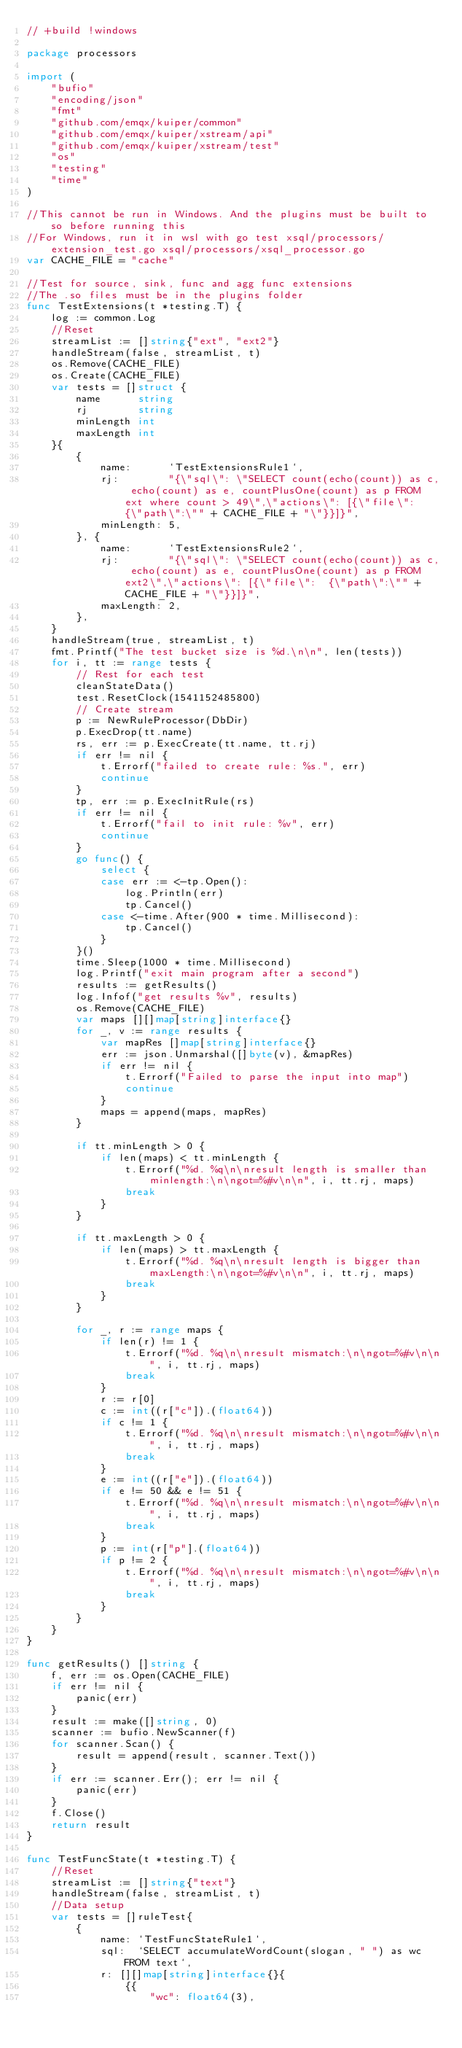Convert code to text. <code><loc_0><loc_0><loc_500><loc_500><_Go_>// +build !windows

package processors

import (
	"bufio"
	"encoding/json"
	"fmt"
	"github.com/emqx/kuiper/common"
	"github.com/emqx/kuiper/xstream/api"
	"github.com/emqx/kuiper/xstream/test"
	"os"
	"testing"
	"time"
)

//This cannot be run in Windows. And the plugins must be built to so before running this
//For Windows, run it in wsl with go test xsql/processors/extension_test.go xsql/processors/xsql_processor.go
var CACHE_FILE = "cache"

//Test for source, sink, func and agg func extensions
//The .so files must be in the plugins folder
func TestExtensions(t *testing.T) {
	log := common.Log
	//Reset
	streamList := []string{"ext", "ext2"}
	handleStream(false, streamList, t)
	os.Remove(CACHE_FILE)
	os.Create(CACHE_FILE)
	var tests = []struct {
		name      string
		rj        string
		minLength int
		maxLength int
	}{
		{
			name:      `TestExtensionsRule1`,
			rj:        "{\"sql\": \"SELECT count(echo(count)) as c, echo(count) as e, countPlusOne(count) as p FROM ext where count > 49\",\"actions\": [{\"file\":  {\"path\":\"" + CACHE_FILE + "\"}}]}",
			minLength: 5,
		}, {
			name:      `TestExtensionsRule2`,
			rj:        "{\"sql\": \"SELECT count(echo(count)) as c, echo(count) as e, countPlusOne(count) as p FROM ext2\",\"actions\": [{\"file\":  {\"path\":\"" + CACHE_FILE + "\"}}]}",
			maxLength: 2,
		},
	}
	handleStream(true, streamList, t)
	fmt.Printf("The test bucket size is %d.\n\n", len(tests))
	for i, tt := range tests {
		// Rest for each test
		cleanStateData()
		test.ResetClock(1541152485800)
		// Create stream
		p := NewRuleProcessor(DbDir)
		p.ExecDrop(tt.name)
		rs, err := p.ExecCreate(tt.name, tt.rj)
		if err != nil {
			t.Errorf("failed to create rule: %s.", err)
			continue
		}
		tp, err := p.ExecInitRule(rs)
		if err != nil {
			t.Errorf("fail to init rule: %v", err)
			continue
		}
		go func() {
			select {
			case err := <-tp.Open():
				log.Println(err)
				tp.Cancel()
			case <-time.After(900 * time.Millisecond):
				tp.Cancel()
			}
		}()
		time.Sleep(1000 * time.Millisecond)
		log.Printf("exit main program after a second")
		results := getResults()
		log.Infof("get results %v", results)
		os.Remove(CACHE_FILE)
		var maps [][]map[string]interface{}
		for _, v := range results {
			var mapRes []map[string]interface{}
			err := json.Unmarshal([]byte(v), &mapRes)
			if err != nil {
				t.Errorf("Failed to parse the input into map")
				continue
			}
			maps = append(maps, mapRes)
		}

		if tt.minLength > 0 {
			if len(maps) < tt.minLength {
				t.Errorf("%d. %q\n\nresult length is smaller than minlength:\n\ngot=%#v\n\n", i, tt.rj, maps)
				break
			}
		}

		if tt.maxLength > 0 {
			if len(maps) > tt.maxLength {
				t.Errorf("%d. %q\n\nresult length is bigger than maxLength:\n\ngot=%#v\n\n", i, tt.rj, maps)
				break
			}
		}

		for _, r := range maps {
			if len(r) != 1 {
				t.Errorf("%d. %q\n\nresult mismatch:\n\ngot=%#v\n\n", i, tt.rj, maps)
				break
			}
			r := r[0]
			c := int((r["c"]).(float64))
			if c != 1 {
				t.Errorf("%d. %q\n\nresult mismatch:\n\ngot=%#v\n\n", i, tt.rj, maps)
				break
			}
			e := int((r["e"]).(float64))
			if e != 50 && e != 51 {
				t.Errorf("%d. %q\n\nresult mismatch:\n\ngot=%#v\n\n", i, tt.rj, maps)
				break
			}
			p := int(r["p"].(float64))
			if p != 2 {
				t.Errorf("%d. %q\n\nresult mismatch:\n\ngot=%#v\n\n", i, tt.rj, maps)
				break
			}
		}
	}
}

func getResults() []string {
	f, err := os.Open(CACHE_FILE)
	if err != nil {
		panic(err)
	}
	result := make([]string, 0)
	scanner := bufio.NewScanner(f)
	for scanner.Scan() {
		result = append(result, scanner.Text())
	}
	if err := scanner.Err(); err != nil {
		panic(err)
	}
	f.Close()
	return result
}

func TestFuncState(t *testing.T) {
	//Reset
	streamList := []string{"text"}
	handleStream(false, streamList, t)
	//Data setup
	var tests = []ruleTest{
		{
			name: `TestFuncStateRule1`,
			sql:  `SELECT accumulateWordCount(slogan, " ") as wc FROM text`,
			r: [][]map[string]interface{}{
				{{
					"wc": float64(3),</code> 